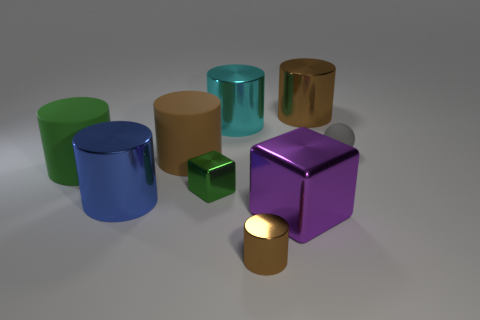There is a brown cylinder that is behind the matte sphere; what number of large metal cylinders are right of it?
Ensure brevity in your answer.  0. How many blue objects are either large metallic things or metallic objects?
Ensure brevity in your answer.  1. There is a green object on the right side of the big brown thing in front of the brown thing that is behind the small rubber thing; what shape is it?
Your answer should be very brief. Cube. What is the color of the matte cylinder that is the same size as the green matte object?
Your answer should be very brief. Brown. What number of big green things have the same shape as the large blue shiny object?
Keep it short and to the point. 1. Does the blue shiny object have the same size as the brown shiny object that is in front of the green cube?
Offer a very short reply. No. The big brown thing that is to the right of the green thing on the right side of the big blue shiny cylinder is what shape?
Keep it short and to the point. Cylinder. Is the number of purple metallic cubes behind the purple object less than the number of small red shiny blocks?
Your response must be concise. No. What shape is the rubber thing that is the same color as the tiny cylinder?
Your answer should be compact. Cylinder. What number of brown metallic things are the same size as the blue shiny cylinder?
Your response must be concise. 1. 